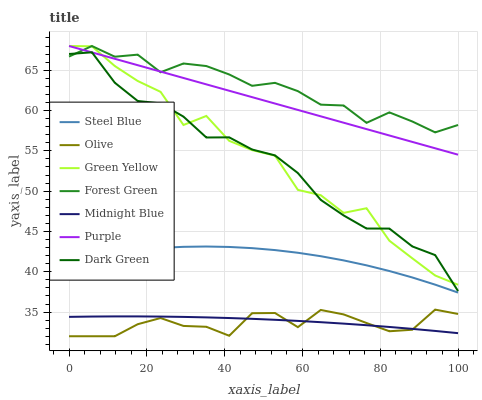Does Olive have the minimum area under the curve?
Answer yes or no. Yes. Does Forest Green have the maximum area under the curve?
Answer yes or no. Yes. Does Purple have the minimum area under the curve?
Answer yes or no. No. Does Purple have the maximum area under the curve?
Answer yes or no. No. Is Purple the smoothest?
Answer yes or no. Yes. Is Green Yellow the roughest?
Answer yes or no. Yes. Is Steel Blue the smoothest?
Answer yes or no. No. Is Steel Blue the roughest?
Answer yes or no. No. Does Olive have the lowest value?
Answer yes or no. Yes. Does Purple have the lowest value?
Answer yes or no. No. Does Green Yellow have the highest value?
Answer yes or no. Yes. Does Steel Blue have the highest value?
Answer yes or no. No. Is Midnight Blue less than Forest Green?
Answer yes or no. Yes. Is Steel Blue greater than Midnight Blue?
Answer yes or no. Yes. Does Olive intersect Midnight Blue?
Answer yes or no. Yes. Is Olive less than Midnight Blue?
Answer yes or no. No. Is Olive greater than Midnight Blue?
Answer yes or no. No. Does Midnight Blue intersect Forest Green?
Answer yes or no. No. 